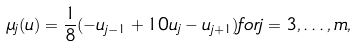<formula> <loc_0><loc_0><loc_500><loc_500>\mu _ { j } ( u ) = \frac { 1 } { 8 } ( - u _ { j - 1 } + 1 0 u _ { j } - u _ { j + 1 } ) f o r j = 3 , \dots , m ,</formula> 